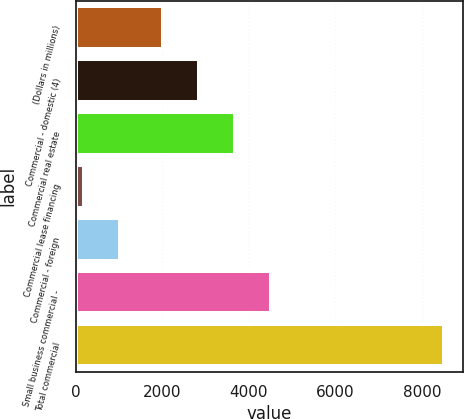<chart> <loc_0><loc_0><loc_500><loc_500><bar_chart><fcel>(Dollars in millions)<fcel>Commercial - domestic (4)<fcel>Commercial real estate<fcel>Commercial lease financing<fcel>Commercial - foreign<fcel>Small business commercial -<fcel>Total commercial<nl><fcel>2009<fcel>2840.5<fcel>3672<fcel>195<fcel>1026.5<fcel>4503.5<fcel>8510<nl></chart> 